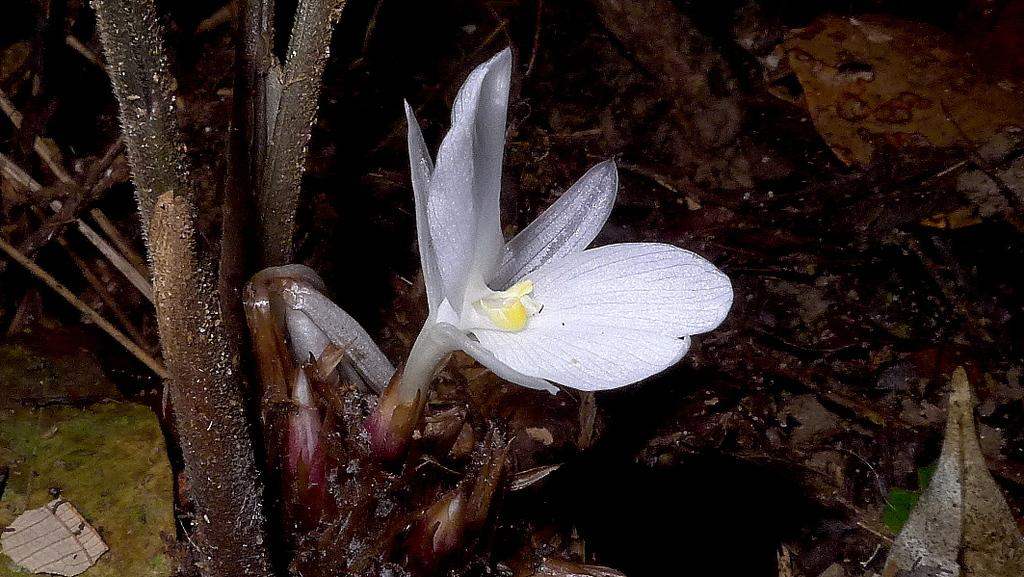What type of flower is visible in the image? There is a white flower in the image. Does the flower belong to a specific type of plant? Yes, the flower belongs to a tree. How many boats are visible in the image? There are no boats present in the image; it features a white flower belonging to a tree. What show is being performed in the image? There is no show being performed in the image; it features a white flower belonging to a tree. 